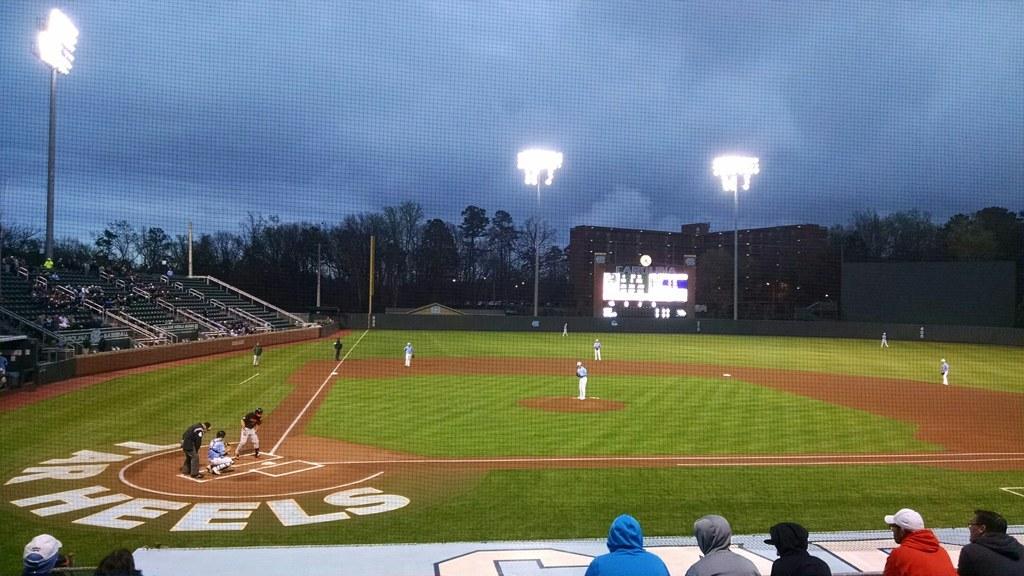This is what team's field?
Ensure brevity in your answer.  Tar heels. 